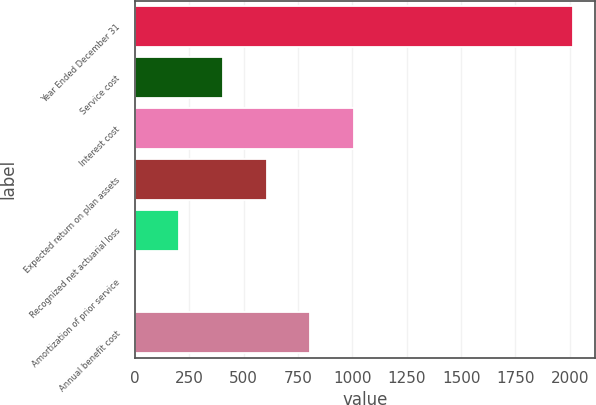Convert chart to OTSL. <chart><loc_0><loc_0><loc_500><loc_500><bar_chart><fcel>Year Ended December 31<fcel>Service cost<fcel>Interest cost<fcel>Expected return on plan assets<fcel>Recognized net actuarial loss<fcel>Amortization of prior service<fcel>Annual benefit cost<nl><fcel>2014<fcel>404.4<fcel>1008<fcel>605.6<fcel>203.2<fcel>2<fcel>806.8<nl></chart> 